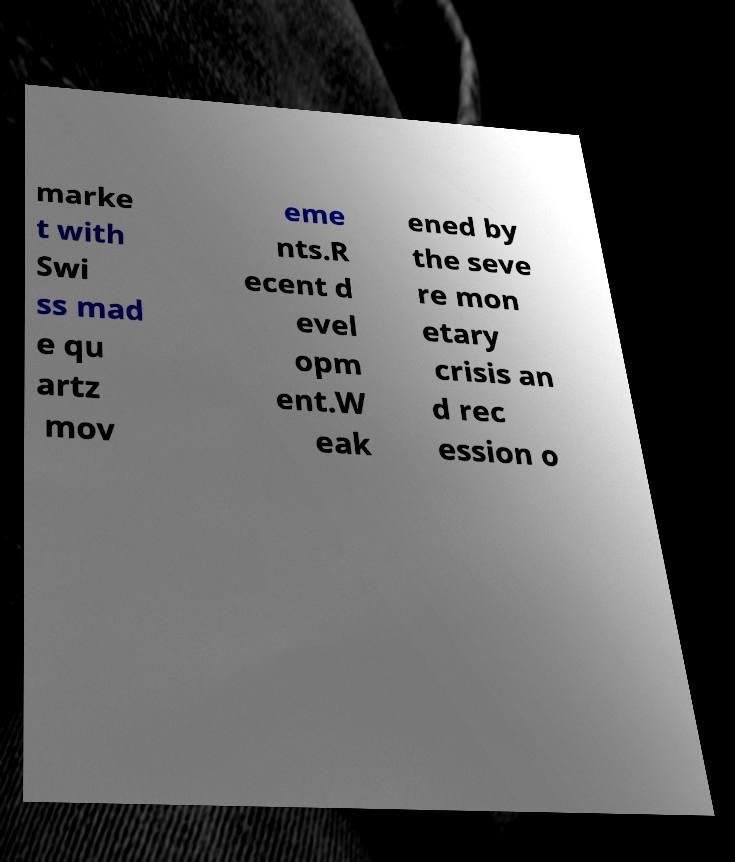Can you accurately transcribe the text from the provided image for me? marke t with Swi ss mad e qu artz mov eme nts.R ecent d evel opm ent.W eak ened by the seve re mon etary crisis an d rec ession o 